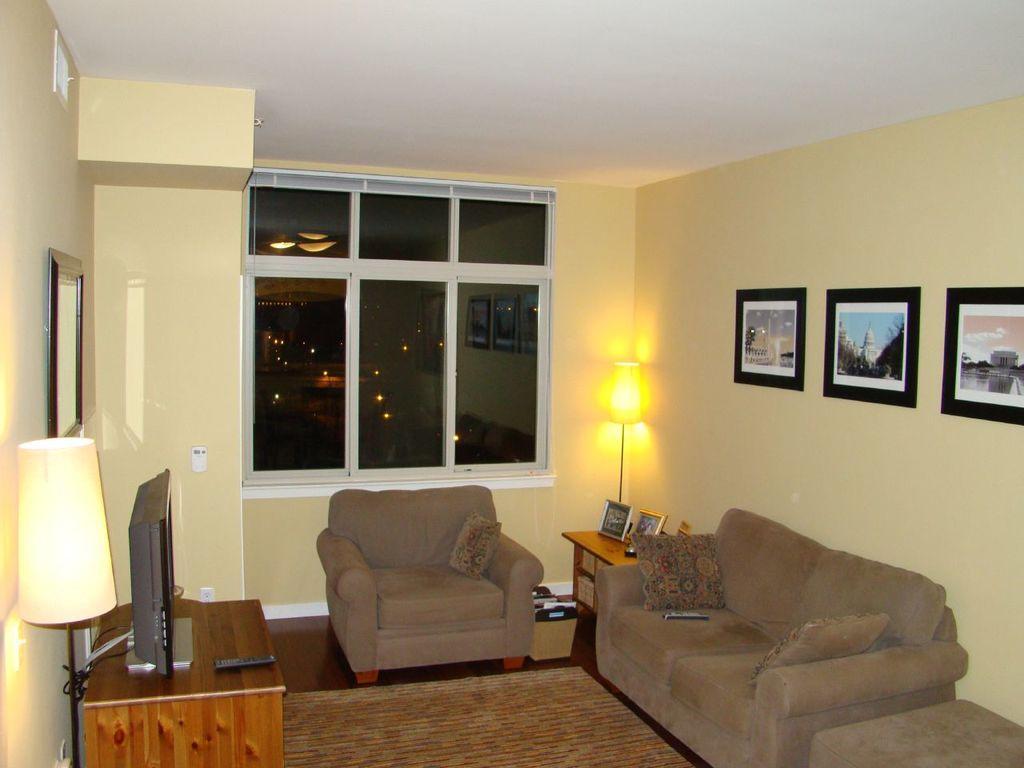Describe this image in one or two sentences. In this picture there is a sofa, a television and a remote on the table, there is a lamp and there is a window. In the background there is a photo frame placed on the wall. 